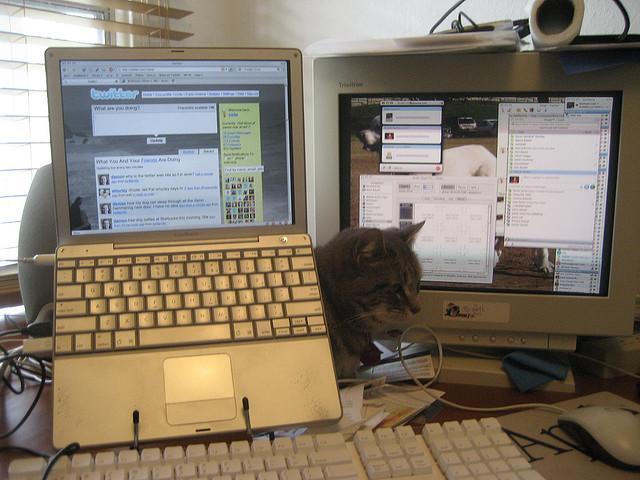What is the cat hiding behind?
Answer the question by selecting the correct answer among the 4 following choices and explain your choice with a short sentence. The answer should be formatted with the following format: `Answer: choice
Rationale: rationale.`
Options: Owners body, laptop, box, couch. Answer: laptop.
Rationale: The cat is laying behind a laptop laying upright. 